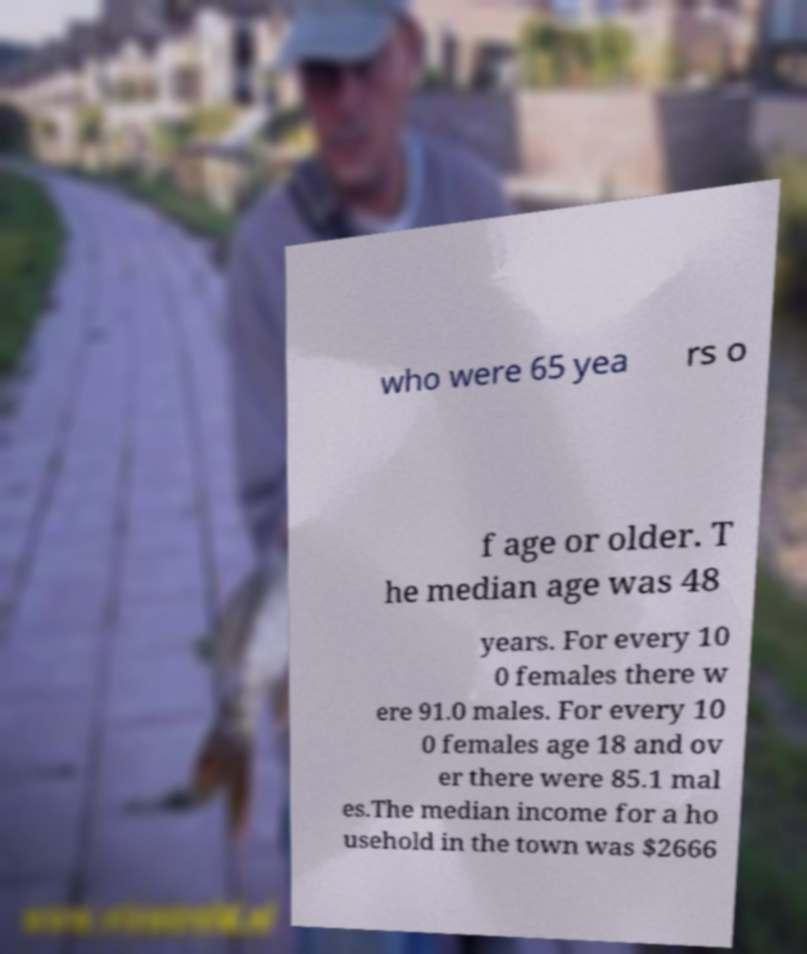Can you accurately transcribe the text from the provided image for me? who were 65 yea rs o f age or older. T he median age was 48 years. For every 10 0 females there w ere 91.0 males. For every 10 0 females age 18 and ov er there were 85.1 mal es.The median income for a ho usehold in the town was $2666 